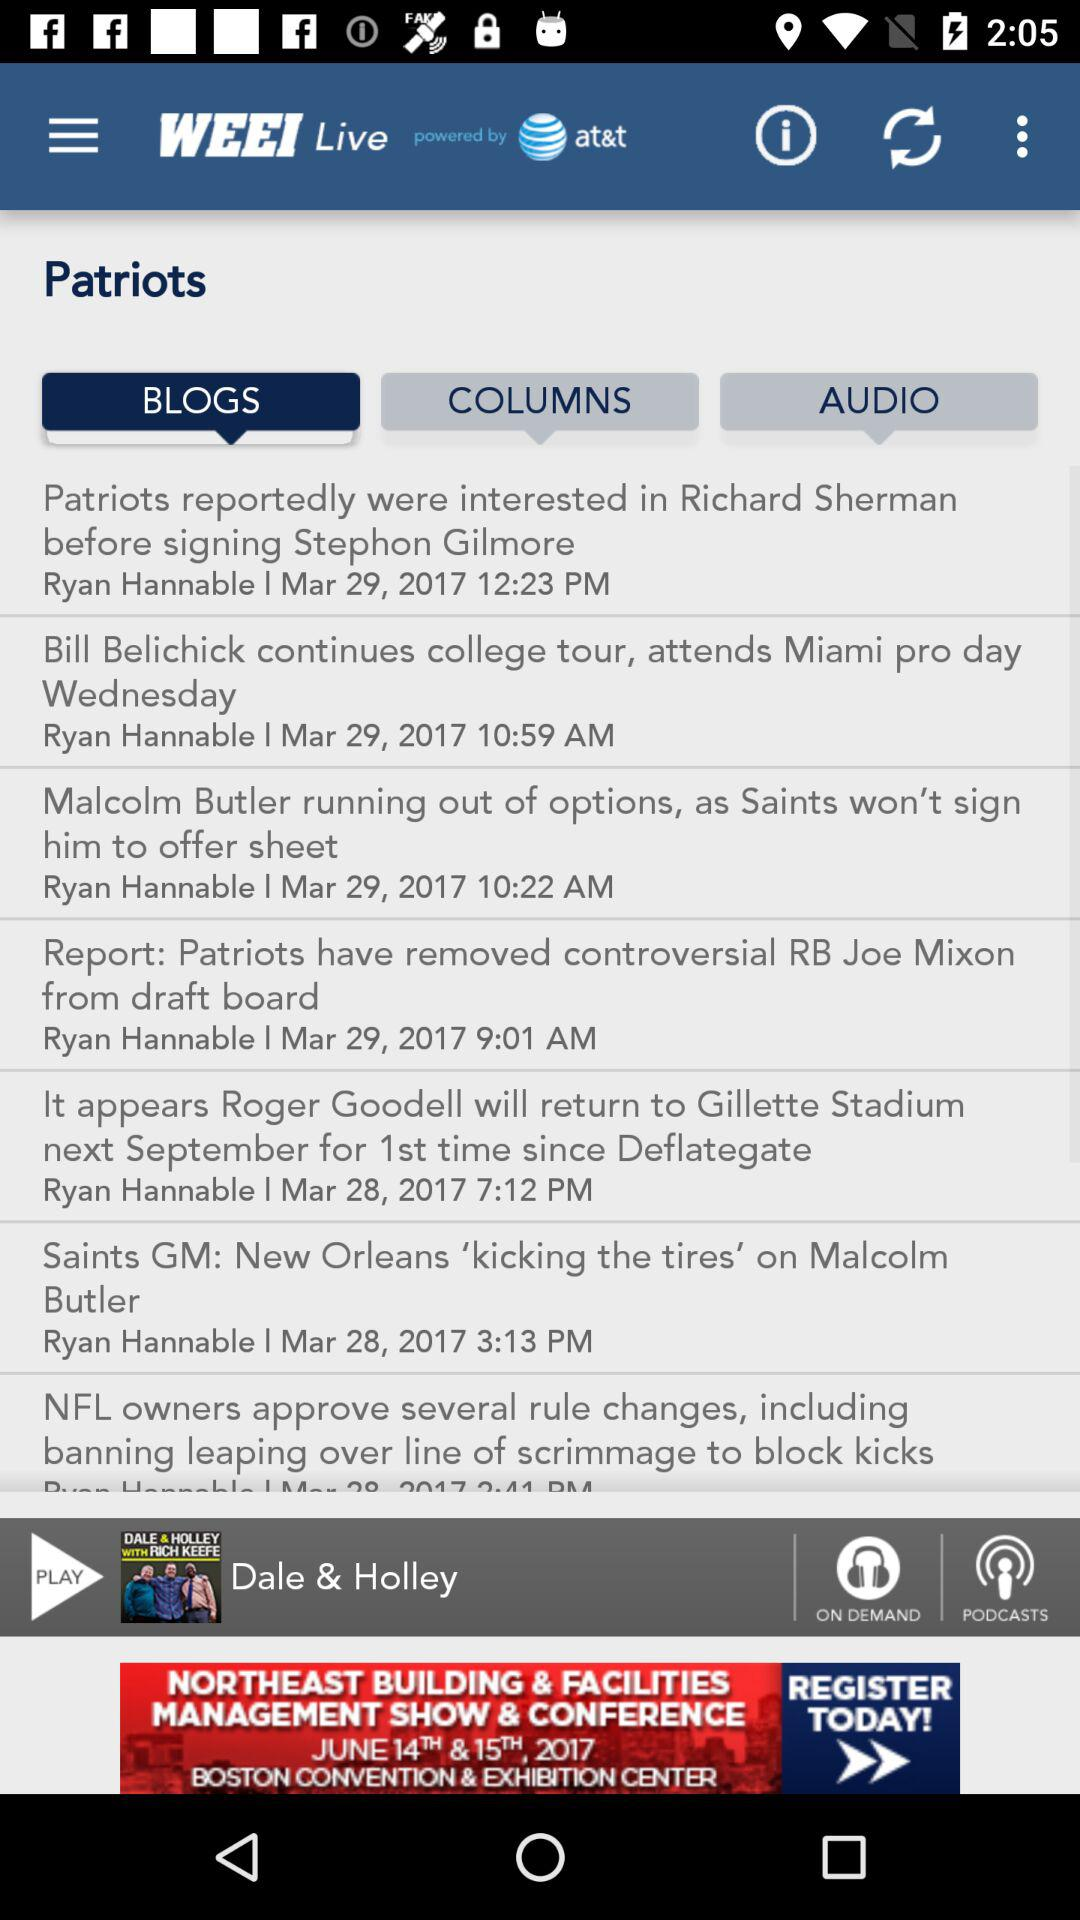Which tab are we on? You are on the "BLOGS" tab. 